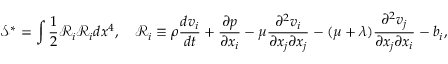Convert formula to latex. <formula><loc_0><loc_0><loc_500><loc_500>\mathcal { S } ^ { * } = \int \frac { 1 } { 2 } \mathcal { R } _ { i } \mathcal { R } _ { i } d x ^ { 4 } , \quad \mathcal { R } _ { i } \equiv \rho \frac { d v _ { i } } { d t } + \frac { \partial p } { \partial x _ { i } } - \mu \frac { \partial ^ { 2 } v _ { i } } { \partial x _ { j } \partial x _ { j } } - ( \mu + \lambda ) \frac { \partial ^ { 2 } v _ { j } } { \partial x _ { j } \partial x _ { i } } - b _ { i } ,</formula> 